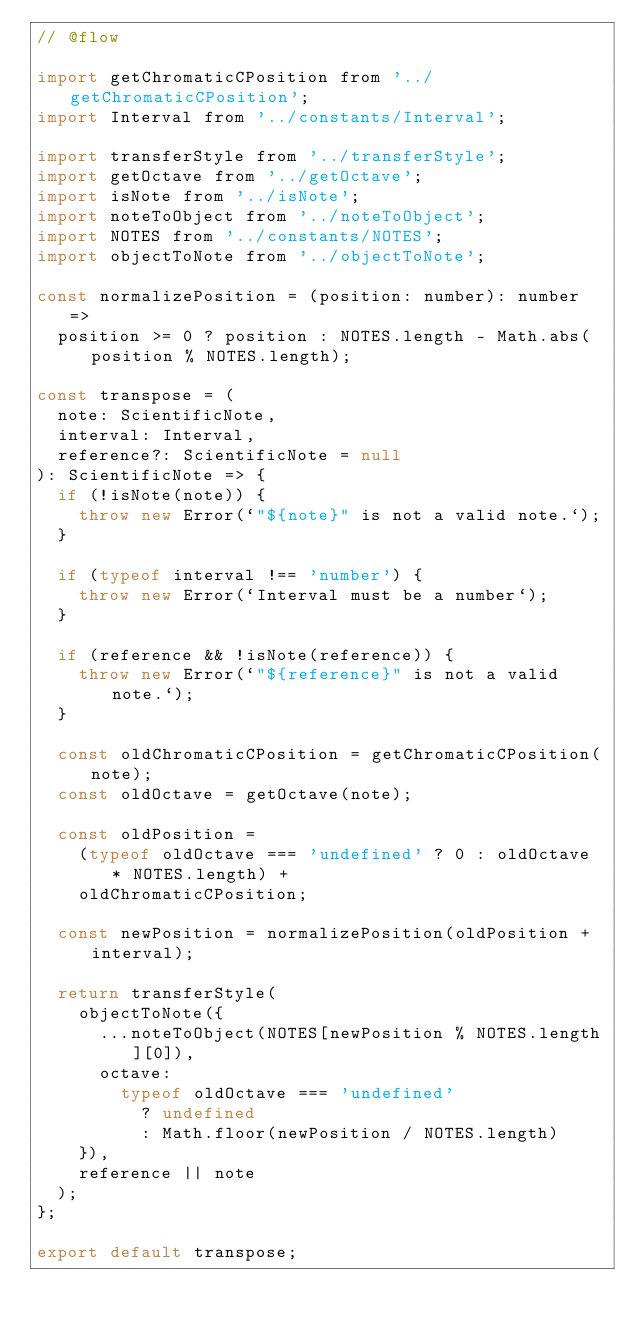<code> <loc_0><loc_0><loc_500><loc_500><_JavaScript_>// @flow

import getChromaticCPosition from '../getChromaticCPosition';
import Interval from '../constants/Interval';

import transferStyle from '../transferStyle';
import getOctave from '../getOctave';
import isNote from '../isNote';
import noteToObject from '../noteToObject';
import NOTES from '../constants/NOTES';
import objectToNote from '../objectToNote';

const normalizePosition = (position: number): number =>
  position >= 0 ? position : NOTES.length - Math.abs(position % NOTES.length);

const transpose = (
  note: ScientificNote,
  interval: Interval,
  reference?: ScientificNote = null
): ScientificNote => {
  if (!isNote(note)) {
    throw new Error(`"${note}" is not a valid note.`);
  }

  if (typeof interval !== 'number') {
    throw new Error(`Interval must be a number`);
  }

  if (reference && !isNote(reference)) {
    throw new Error(`"${reference}" is not a valid note.`);
  }

  const oldChromaticCPosition = getChromaticCPosition(note);
  const oldOctave = getOctave(note);

  const oldPosition =
    (typeof oldOctave === 'undefined' ? 0 : oldOctave * NOTES.length) +
    oldChromaticCPosition;

  const newPosition = normalizePosition(oldPosition + interval);

  return transferStyle(
    objectToNote({
      ...noteToObject(NOTES[newPosition % NOTES.length][0]),
      octave:
        typeof oldOctave === 'undefined'
          ? undefined
          : Math.floor(newPosition / NOTES.length)
    }),
    reference || note
  );
};

export default transpose;
</code> 